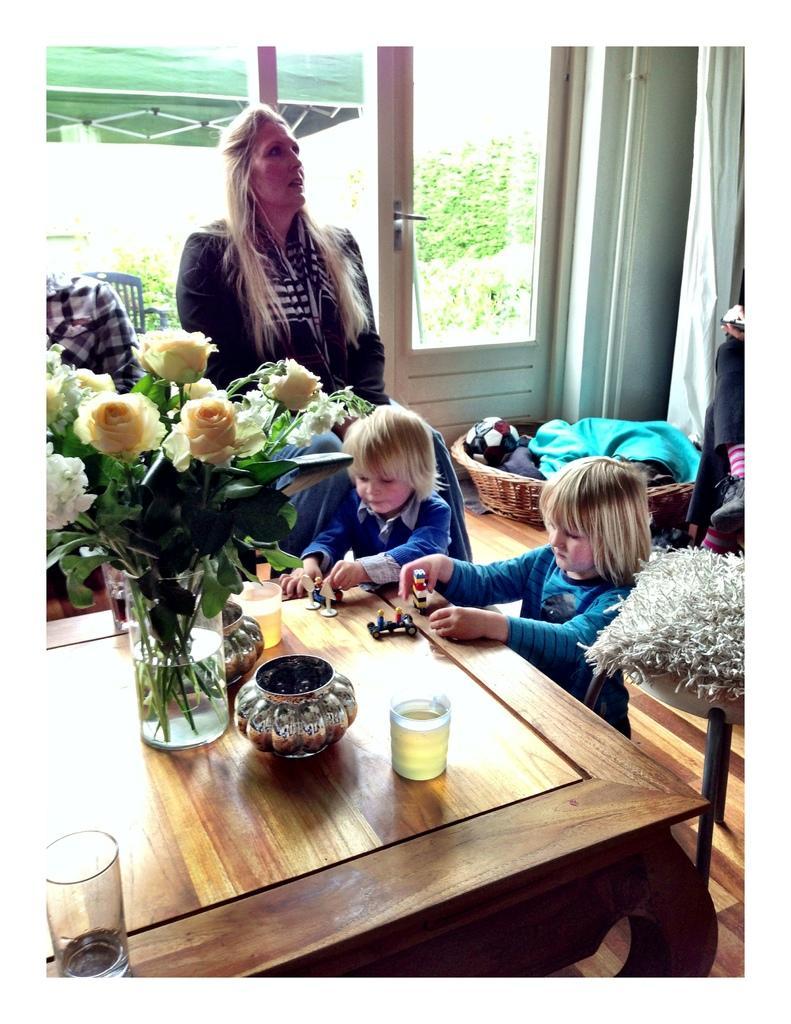Please provide a concise description of this image. In this picture there are two children who are holding an object in their hands. There is a glass, bowl and flowers in the glass. There is a woman standing and there is also another person. There is a chair. There is a basket and clothes. There is a tree at the background. 